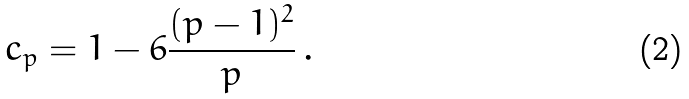<formula> <loc_0><loc_0><loc_500><loc_500>c _ { p } = 1 - 6 \frac { ( p - 1 ) ^ { 2 } } { p } \, .</formula> 